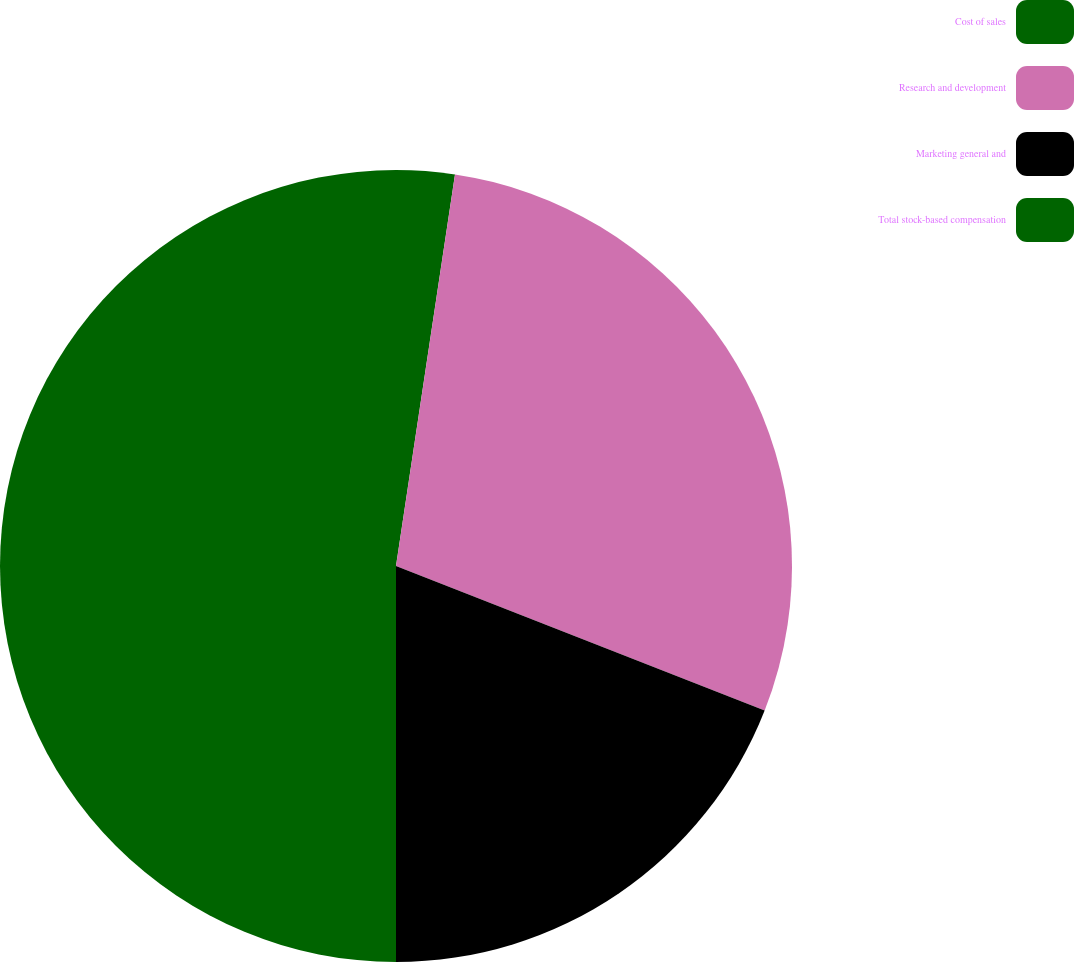Convert chart to OTSL. <chart><loc_0><loc_0><loc_500><loc_500><pie_chart><fcel>Cost of sales<fcel>Research and development<fcel>Marketing general and<fcel>Total stock-based compensation<nl><fcel>2.38%<fcel>28.57%<fcel>19.05%<fcel>50.0%<nl></chart> 